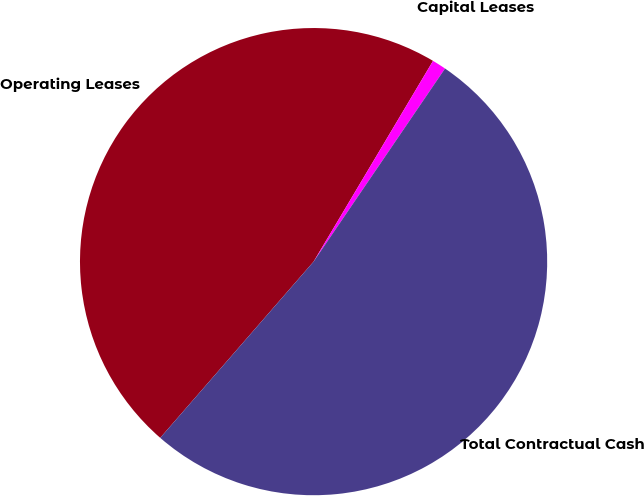Convert chart to OTSL. <chart><loc_0><loc_0><loc_500><loc_500><pie_chart><fcel>Operating Leases<fcel>Capital Leases<fcel>Total Contractual Cash<nl><fcel>47.14%<fcel>0.97%<fcel>51.88%<nl></chart> 